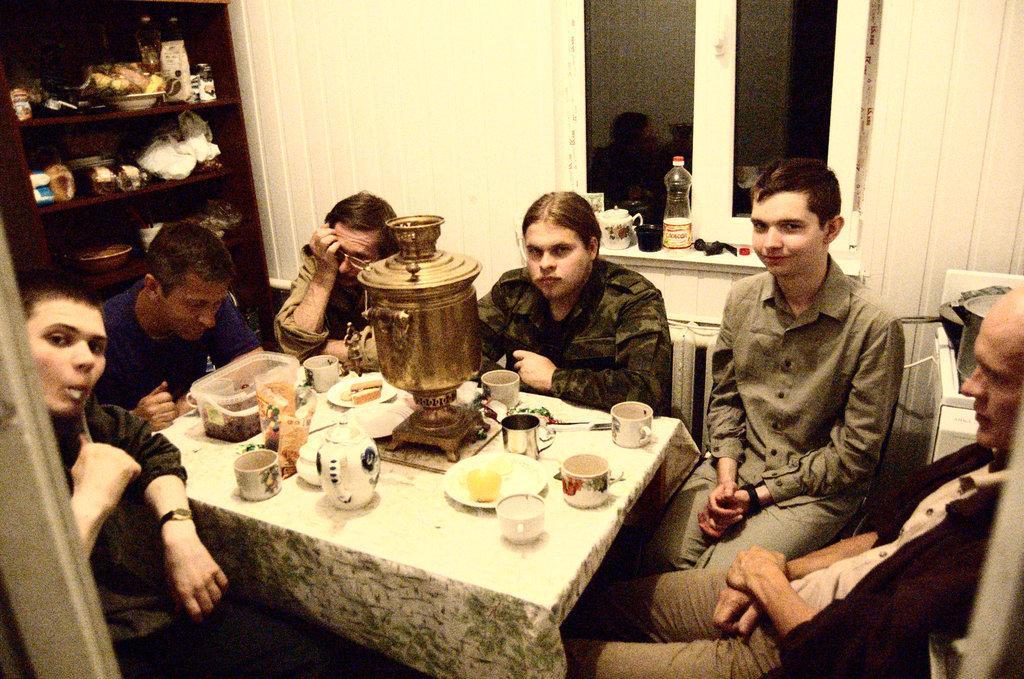Please provide a concise description of this image. In this image there are six person sitting on the chair in front of them there is table on table there is cup,saucer,jar and the plastic box. On the left-side there is a cupboard. we can see a wall. 